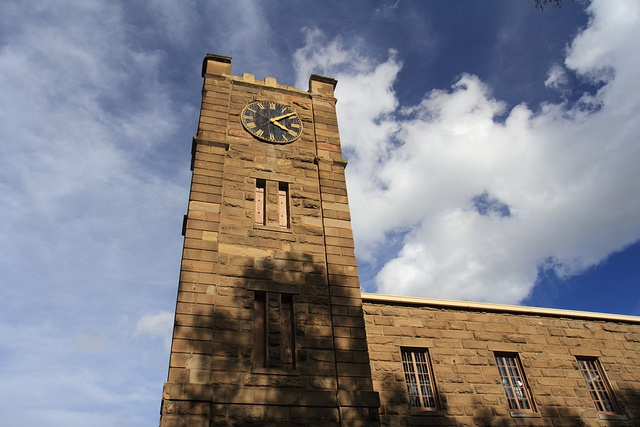Describe the objects in this image and their specific colors. I can see a clock in gray, black, and tan tones in this image. 